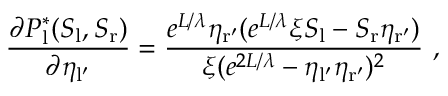Convert formula to latex. <formula><loc_0><loc_0><loc_500><loc_500>\frac { \partial P _ { l } ^ { * } ( S _ { l } , S _ { r } ) } { \partial \eta _ { l ^ { \prime } } } = \frac { e ^ { L / \lambda } \eta _ { r ^ { \prime } } ( e ^ { L / \lambda } \xi S _ { l } - S _ { r } \eta _ { r ^ { \prime } } ) } { \xi ( e ^ { 2 L / \lambda } - \eta _ { l ^ { \prime } } \eta _ { r ^ { \prime } } ) ^ { 2 } } \ ,</formula> 